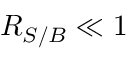Convert formula to latex. <formula><loc_0><loc_0><loc_500><loc_500>R _ { S / B } \ll 1</formula> 